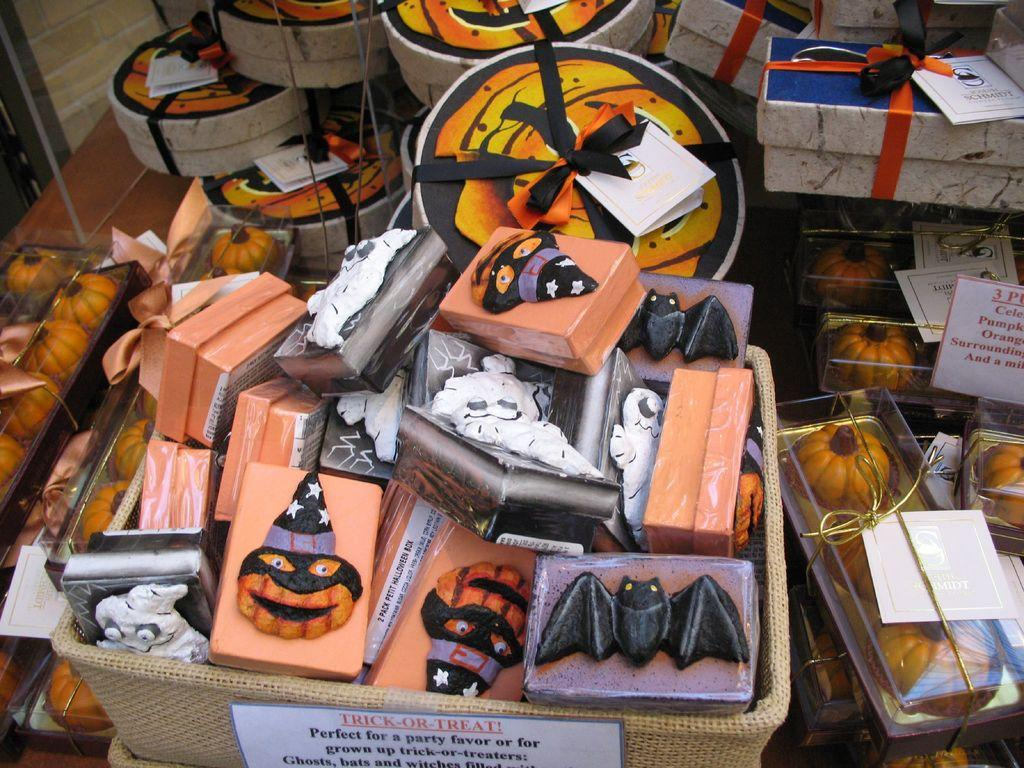What is inside the basket in the image? There are boxes in the basket. What is inside the boxes in the image? Pumpkins are packed in the boxes. What type of items are visible in the image besides the boxes and pumpkins? There are gift boxes in the image. What is on the gift boxes in the image? There are papers on the gift boxes. Can you see a horse playing with the pumpkins in the image? There is no horse present in the image, and the pumpkins are packed in boxes, not being played with. 